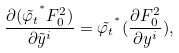Convert formula to latex. <formula><loc_0><loc_0><loc_500><loc_500>{ \frac { \partial ( \tilde { \varphi _ { t } } ^ { ^ { * } } F _ { 0 } ^ { 2 } ) } { \partial \tilde { y } ^ { i } } } = \tilde { \varphi _ { t } } ^ { ^ { * } } ( \frac { \partial F _ { 0 } ^ { 2 } } { \partial y ^ { i } } ) ,</formula> 